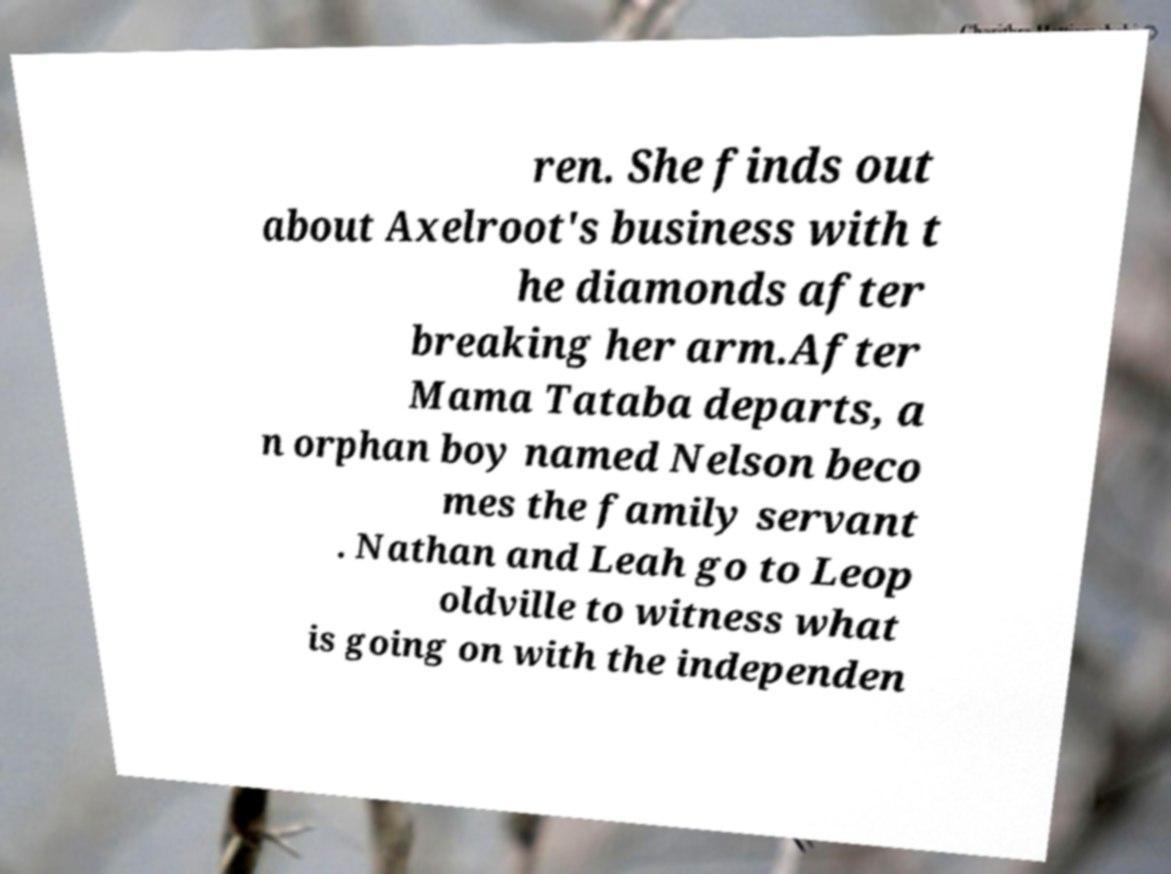Please read and relay the text visible in this image. What does it say? ren. She finds out about Axelroot's business with t he diamonds after breaking her arm.After Mama Tataba departs, a n orphan boy named Nelson beco mes the family servant . Nathan and Leah go to Leop oldville to witness what is going on with the independen 